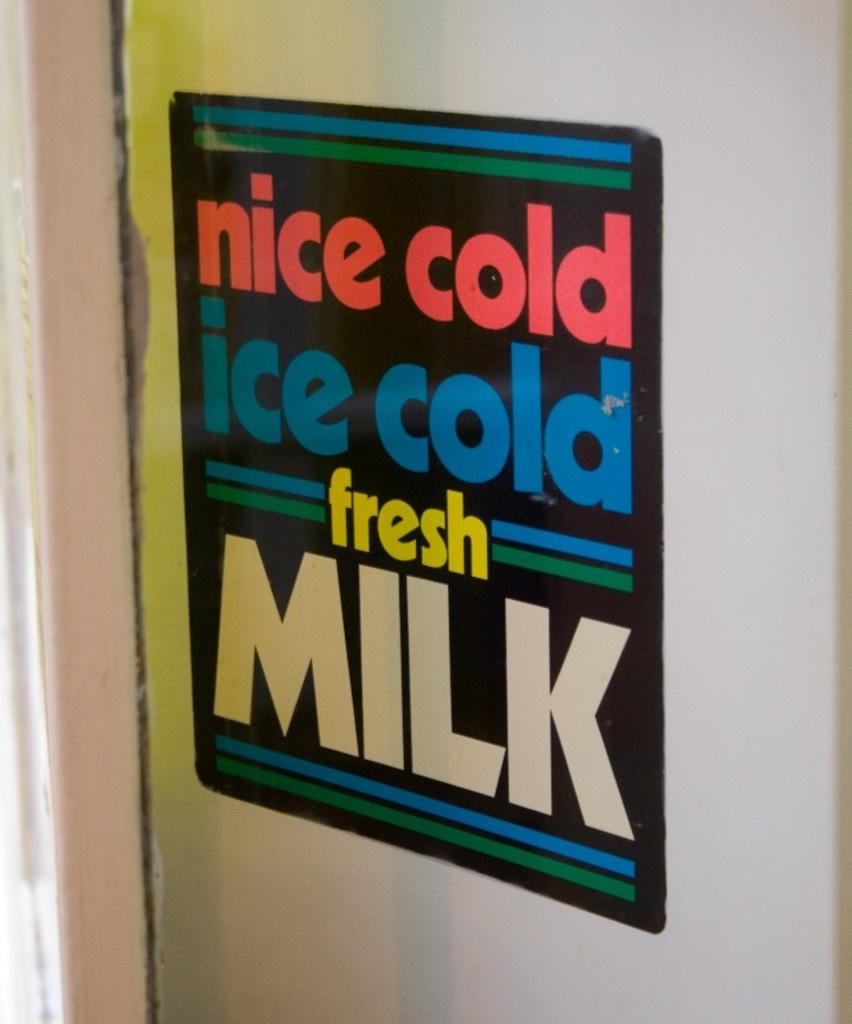<image>
Present a compact description of the photo's key features. A sign advertising nice cold, ice cold fresh milk. 